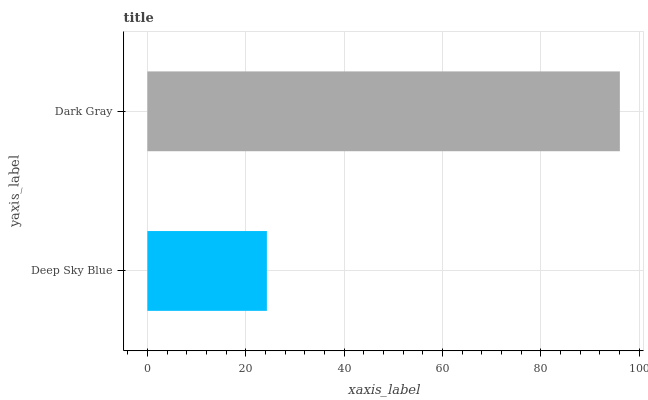Is Deep Sky Blue the minimum?
Answer yes or no. Yes. Is Dark Gray the maximum?
Answer yes or no. Yes. Is Dark Gray the minimum?
Answer yes or no. No. Is Dark Gray greater than Deep Sky Blue?
Answer yes or no. Yes. Is Deep Sky Blue less than Dark Gray?
Answer yes or no. Yes. Is Deep Sky Blue greater than Dark Gray?
Answer yes or no. No. Is Dark Gray less than Deep Sky Blue?
Answer yes or no. No. Is Dark Gray the high median?
Answer yes or no. Yes. Is Deep Sky Blue the low median?
Answer yes or no. Yes. Is Deep Sky Blue the high median?
Answer yes or no. No. Is Dark Gray the low median?
Answer yes or no. No. 